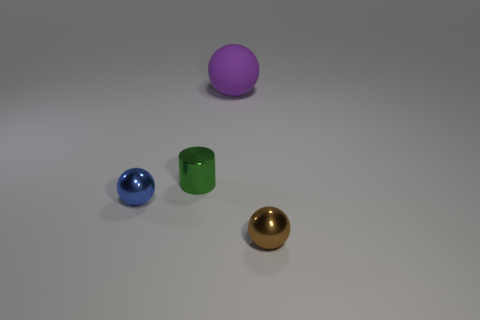Are there any other things that have the same material as the purple ball?
Make the answer very short. No. Is there any other thing that is the same size as the purple rubber object?
Give a very brief answer. No. There is a rubber object; does it have the same size as the thing to the right of the large rubber object?
Provide a succinct answer. No. Does the blue object have the same material as the large purple ball?
Offer a very short reply. No. How many objects are tiny metal cylinders or tiny yellow shiny spheres?
Provide a short and direct response. 1. There is a tiny thing behind the blue object; what is its shape?
Make the answer very short. Cylinder. What color is the other small ball that is made of the same material as the blue ball?
Provide a short and direct response. Brown. There is a big purple object that is the same shape as the blue thing; what is its material?
Offer a terse response. Rubber. What shape is the rubber thing?
Provide a succinct answer. Sphere. There is a tiny object that is both to the right of the tiny blue object and to the left of the small brown metal thing; what is its material?
Give a very brief answer. Metal. 